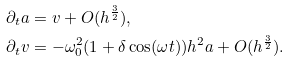<formula> <loc_0><loc_0><loc_500><loc_500>\partial _ { t } a & = v + O ( h ^ { \frac { 3 } { 2 } } ) , \\ \partial _ { t } v & = - \omega _ { 0 } ^ { 2 } ( 1 + \delta \cos ( \omega t ) ) h ^ { 2 } a + O ( h ^ { \frac { 3 } { 2 } } ) .</formula> 